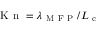<formula> <loc_0><loc_0><loc_500><loc_500>K n = \lambda _ { M F P } / L _ { c }</formula> 